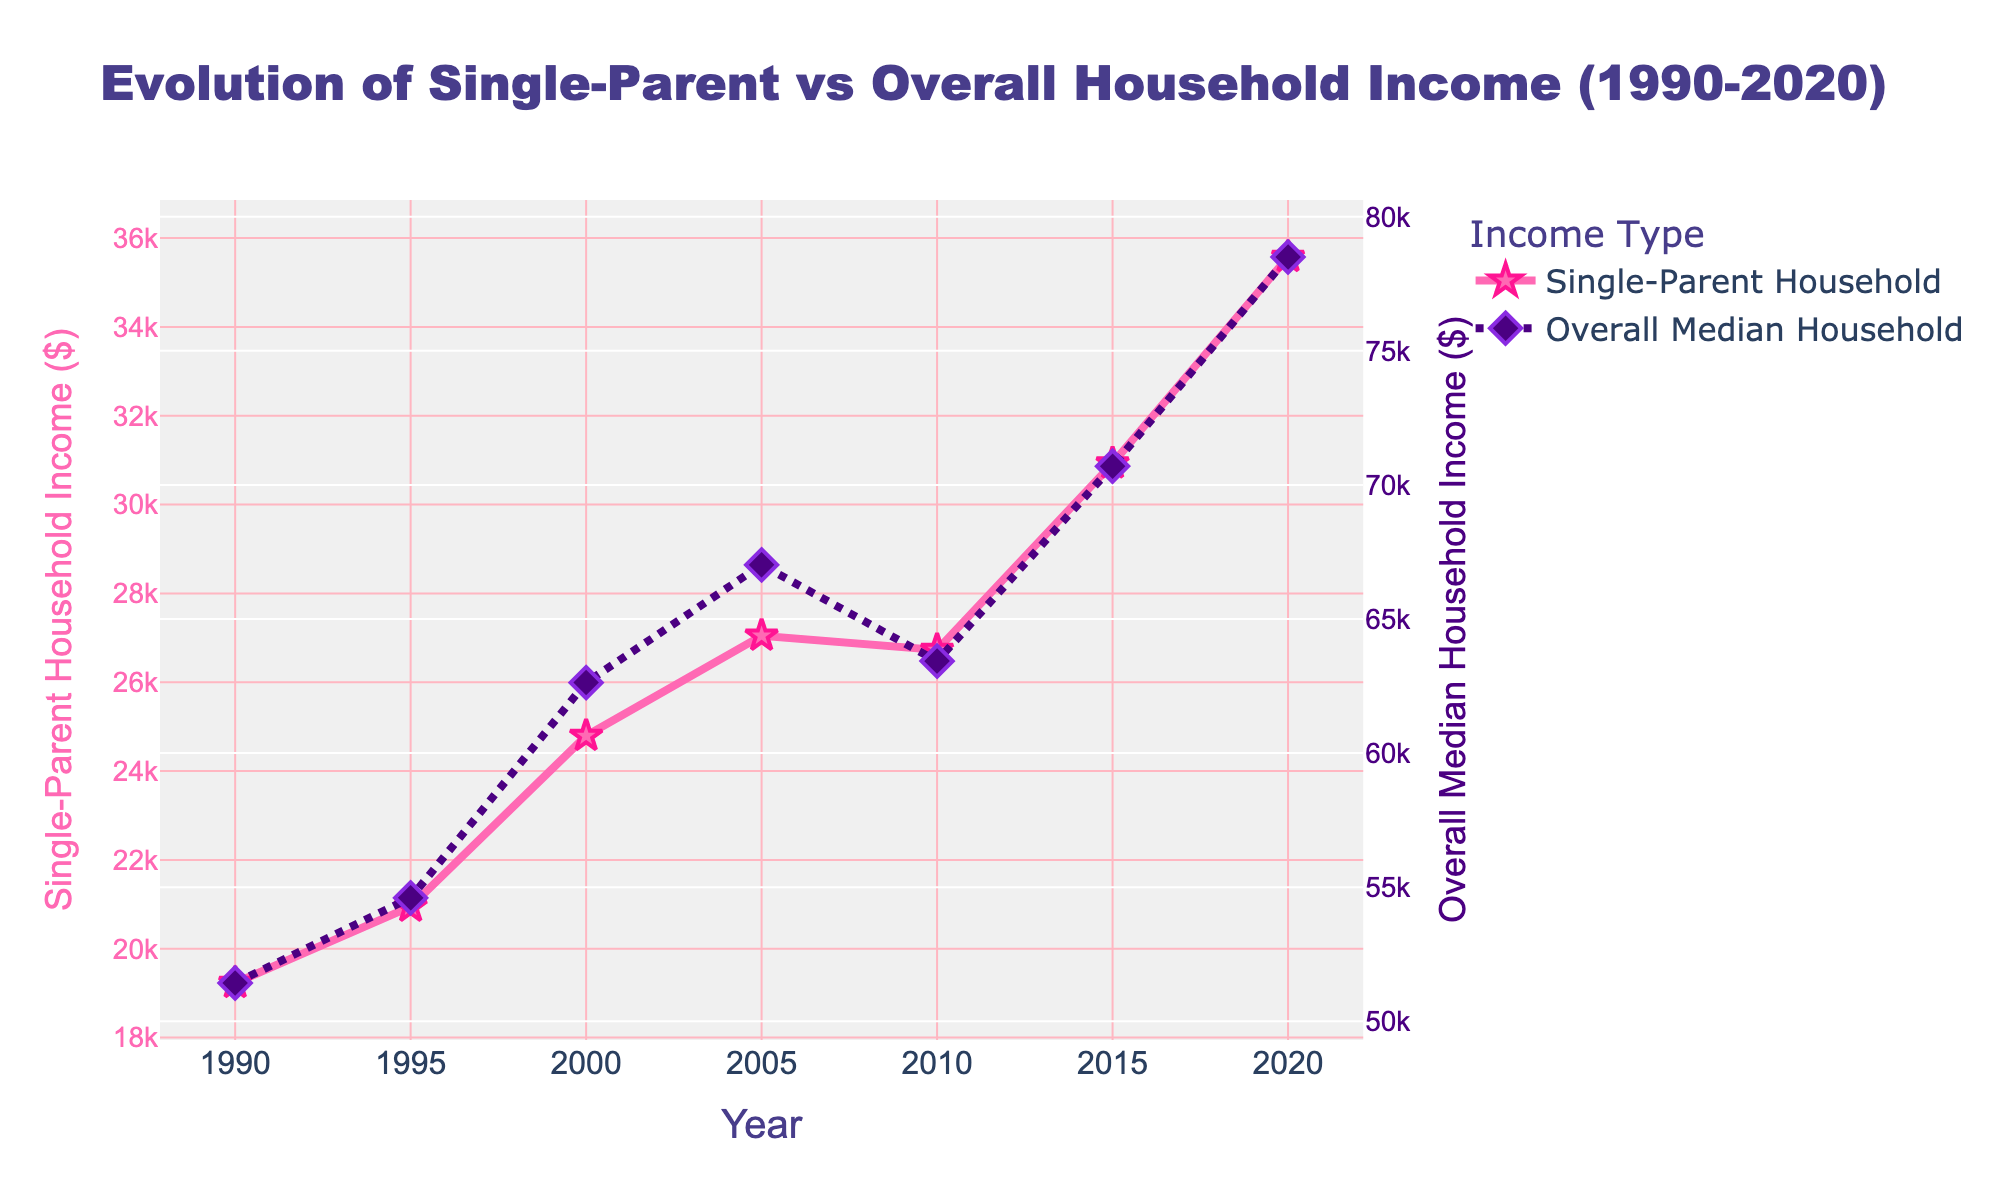What is the difference in median income between Single-Parent and Overall Median Household in 2020? The median income for Single-Parent households in 2020 is $35,574 and for Overall Median households, it is $78,500. Subtracting these two gives $78,500 - $35,574.
Answer: $42,926 Which year had the smallest gap between Single-Parent and Overall Median Household Income? By inspecting the distances between the lines for each year, the smallest gap appears in 1995 where the difference is the smallest.
Answer: 1995 What is the average median income for Single-Parent households over the 30-year period? Adding up all the Single-Parent incomes from the data (19228+20945+24793+27047+26728+30926+35574) and dividing by 7 (number of years) gives (185241/7).
Answer: $26,463 In which year did the Single-Parent Household Median Income see the highest increase from the previous data point? By looking at the year-to-year differences, the highest increase is between 2015 and 2020 with an increase of $4,648.
Answer: 2015 to 2020 What is the percentage increase in median income for Single-Parent households from 1990 to 2020? Calculate the increase by (35574 - 19228) and then compute the percentage increase by [(increase/initial value) × 100] → (16346/19228) × 100.
Answer: 85% Which type of household saw a greater net increase in median income from 1990 to 2020? Calculate the net difference for both: Single-Parent (35574 - 19228) = $16,346 and Overall Median (78500 - 51425) = $27,075; compare these values.
Answer: Overall Median Household How did the trend of Overall Median Household Income change between 2010 and 2015? The income increased from $63,430 in 2010 to $70,697 in 2015, implying a rising trend during these years.
Answer: Rising What is the visual difference in the style of lines used for representing Single-Parent and Overall Median Household incomes? The Single-Parent line is solid pink with star markers while the Overall Median line is dot-dashed purple with diamond markers.
Answer: Solid pink vs Dot-dashed purple Which year shows the highest median income for Single-Parent households? By identifying the peak point on the Single-Parent line, it is 2020 at $35,574.
Answer: 2020 